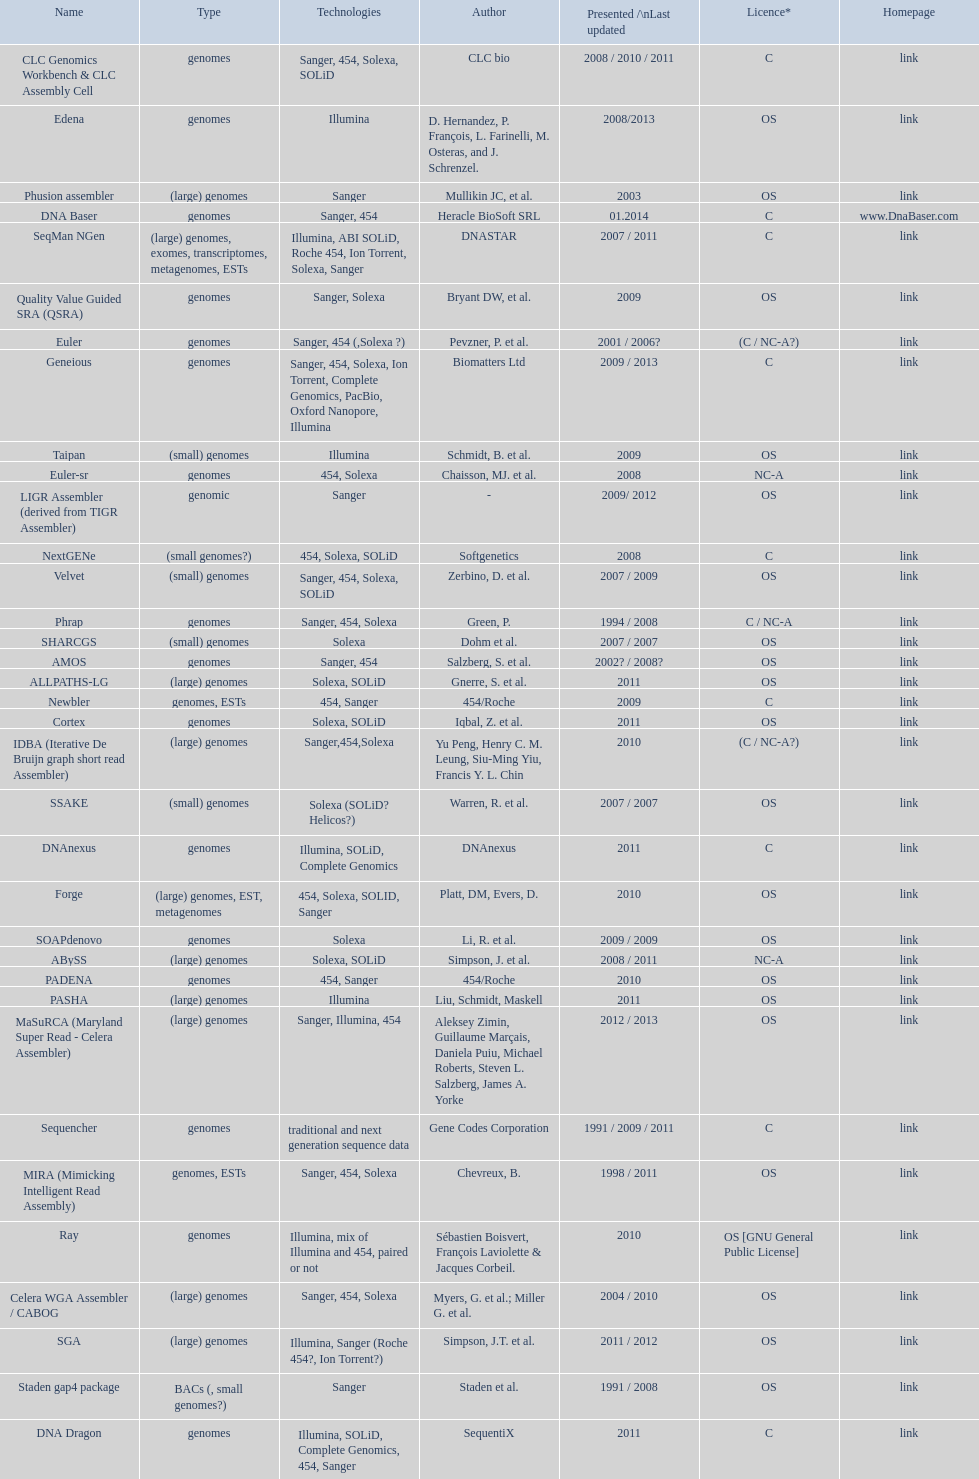Which license is listed more, os or c? OS. 